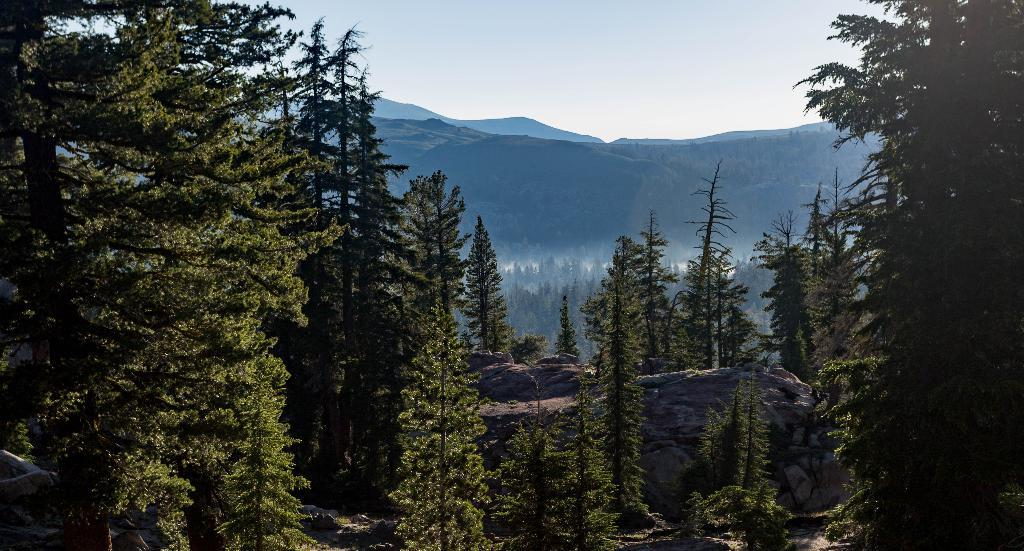What type of natural formation can be seen in the image? There are mountains in the image. What else can be seen in the image besides the mountains? There are many trees and a rock in the image. What part of the natural environment is visible in the image? The sky is visible in the image. What type of steel structure can be seen in the image? There is no steel structure present in the image; it features mountains, trees, a rock, and the sky. What type of reward is being given to the trees in the image? There is no reward being given to the trees in the image; it simply shows trees in their natural environment. 